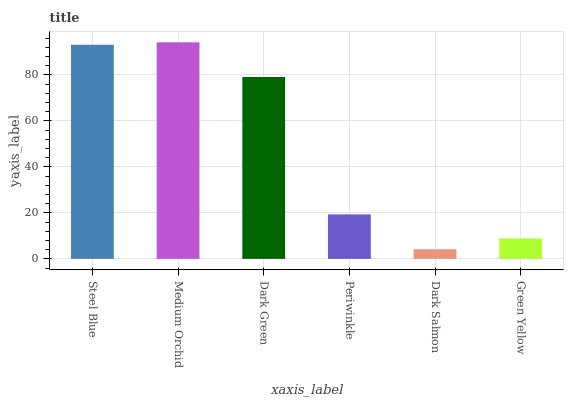Is Dark Salmon the minimum?
Answer yes or no. Yes. Is Medium Orchid the maximum?
Answer yes or no. Yes. Is Dark Green the minimum?
Answer yes or no. No. Is Dark Green the maximum?
Answer yes or no. No. Is Medium Orchid greater than Dark Green?
Answer yes or no. Yes. Is Dark Green less than Medium Orchid?
Answer yes or no. Yes. Is Dark Green greater than Medium Orchid?
Answer yes or no. No. Is Medium Orchid less than Dark Green?
Answer yes or no. No. Is Dark Green the high median?
Answer yes or no. Yes. Is Periwinkle the low median?
Answer yes or no. Yes. Is Periwinkle the high median?
Answer yes or no. No. Is Green Yellow the low median?
Answer yes or no. No. 